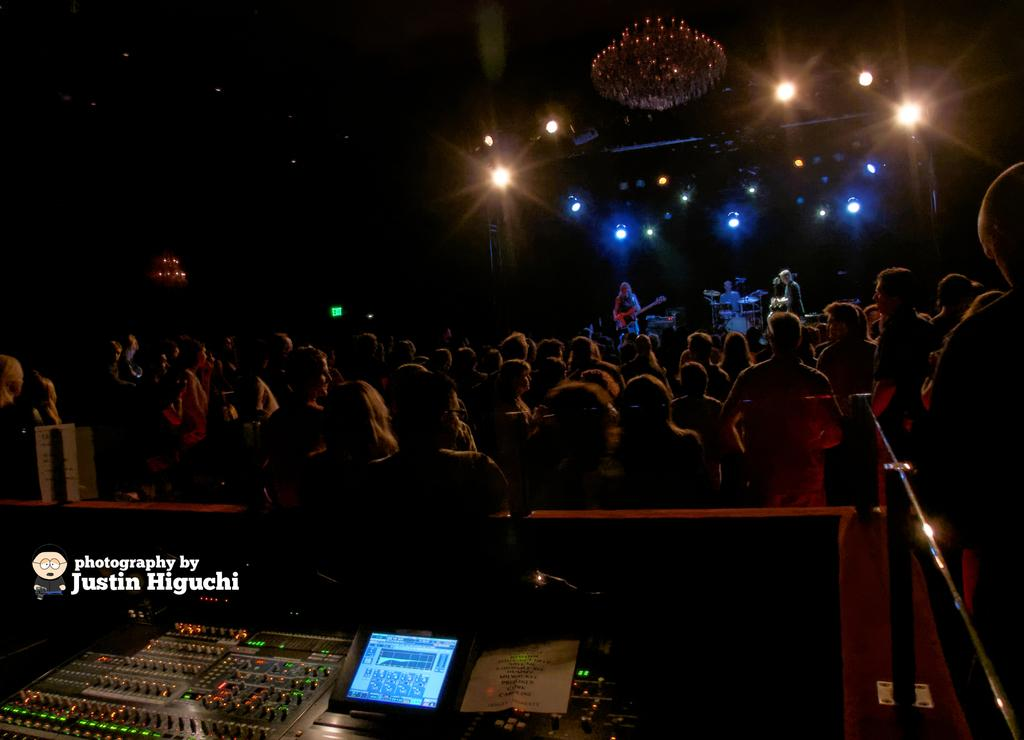What type of device is visible in the image? There is a groove box in the image. What can be seen on the groove box? There is a screen on the groove box. Who is present in the image? People are present in the image. What are the people doing in the image? People are performing and playing musical instruments in the image. What type of lighting is present in the image? There are lights in the image, including a chandelier. Can you tell me how many ladybugs are crawling on the groove box in the image? There are no ladybugs present on the groove box or in the image. What type of animal is playing the musical instrument in the image? There are no animals present in the image; only people are playing musical instruments. 